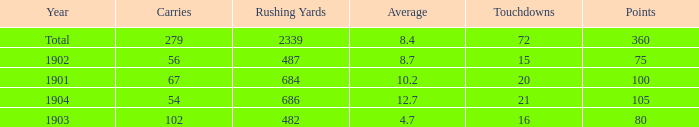Write the full table. {'header': ['Year', 'Carries', 'Rushing Yards', 'Average', 'Touchdowns', 'Points'], 'rows': [['Total', '279', '2339', '8.4', '72', '360'], ['1902', '56', '487', '8.7', '15', '75'], ['1901', '67', '684', '10.2', '20', '100'], ['1904', '54', '686', '12.7', '21', '105'], ['1903', '102', '482', '4.7', '16', '80']]} How many carries have an average under 8.7 and touchdowns of 72? 1.0. 